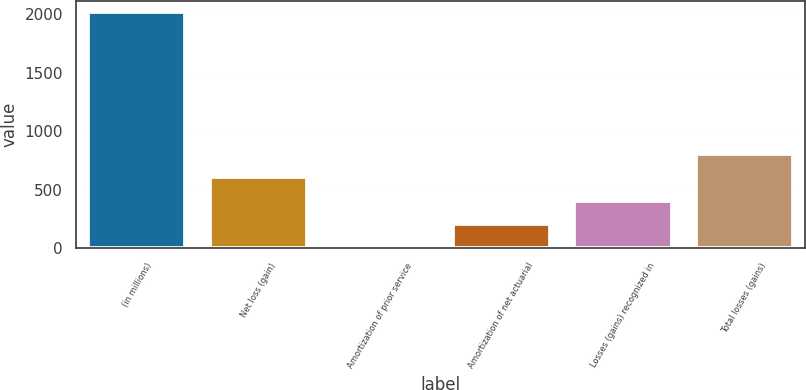Convert chart to OTSL. <chart><loc_0><loc_0><loc_500><loc_500><bar_chart><fcel>(in millions)<fcel>Net loss (gain)<fcel>Amortization of prior service<fcel>Amortization of net actuarial<fcel>Losses (gains) recognized in<fcel>Total losses (gains)<nl><fcel>2015<fcel>606.6<fcel>3<fcel>204.2<fcel>405.4<fcel>807.8<nl></chart> 